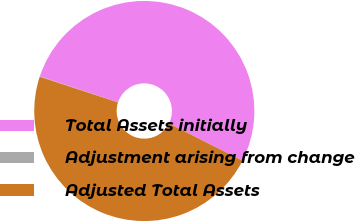<chart> <loc_0><loc_0><loc_500><loc_500><pie_chart><fcel>Total Assets initially<fcel>Adjustment arising from change<fcel>Adjusted Total Assets<nl><fcel>52.34%<fcel>0.07%<fcel>47.58%<nl></chart> 